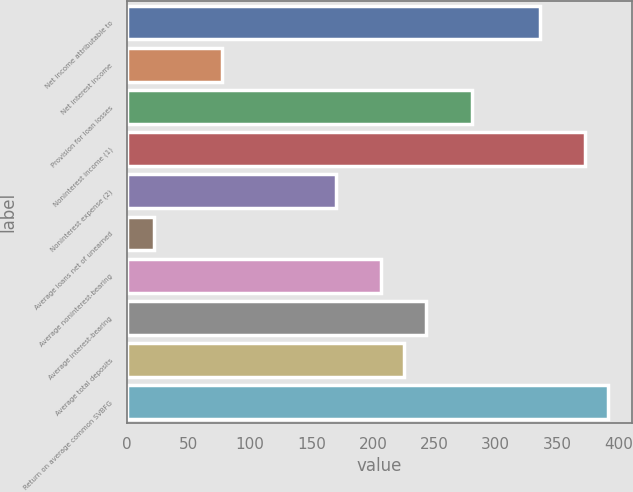<chart> <loc_0><loc_0><loc_500><loc_500><bar_chart><fcel>Net income attributable to<fcel>Net interest income<fcel>Provision for loan losses<fcel>Noninterest income (1)<fcel>Noninterest expense (2)<fcel>Average loans net of unearned<fcel>Average noninterest-bearing<fcel>Average interest-bearing<fcel>Average total deposits<fcel>Return on average common SVBFG<nl><fcel>335.62<fcel>77.46<fcel>280.3<fcel>372.5<fcel>169.66<fcel>22.14<fcel>206.54<fcel>243.42<fcel>224.98<fcel>390.94<nl></chart> 